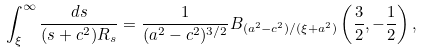Convert formula to latex. <formula><loc_0><loc_0><loc_500><loc_500>\int _ { \xi } ^ { \infty } \frac { d s } { ( s + c ^ { 2 } ) R _ { s } } = \frac { 1 } { ( a ^ { 2 } - c ^ { 2 } ) ^ { 3 / 2 } } B _ { ( a ^ { 2 } - c ^ { 2 } ) / ( \xi + a ^ { 2 } ) } \left ( \frac { 3 } { 2 } , - \frac { 1 } { 2 } \right ) ,</formula> 